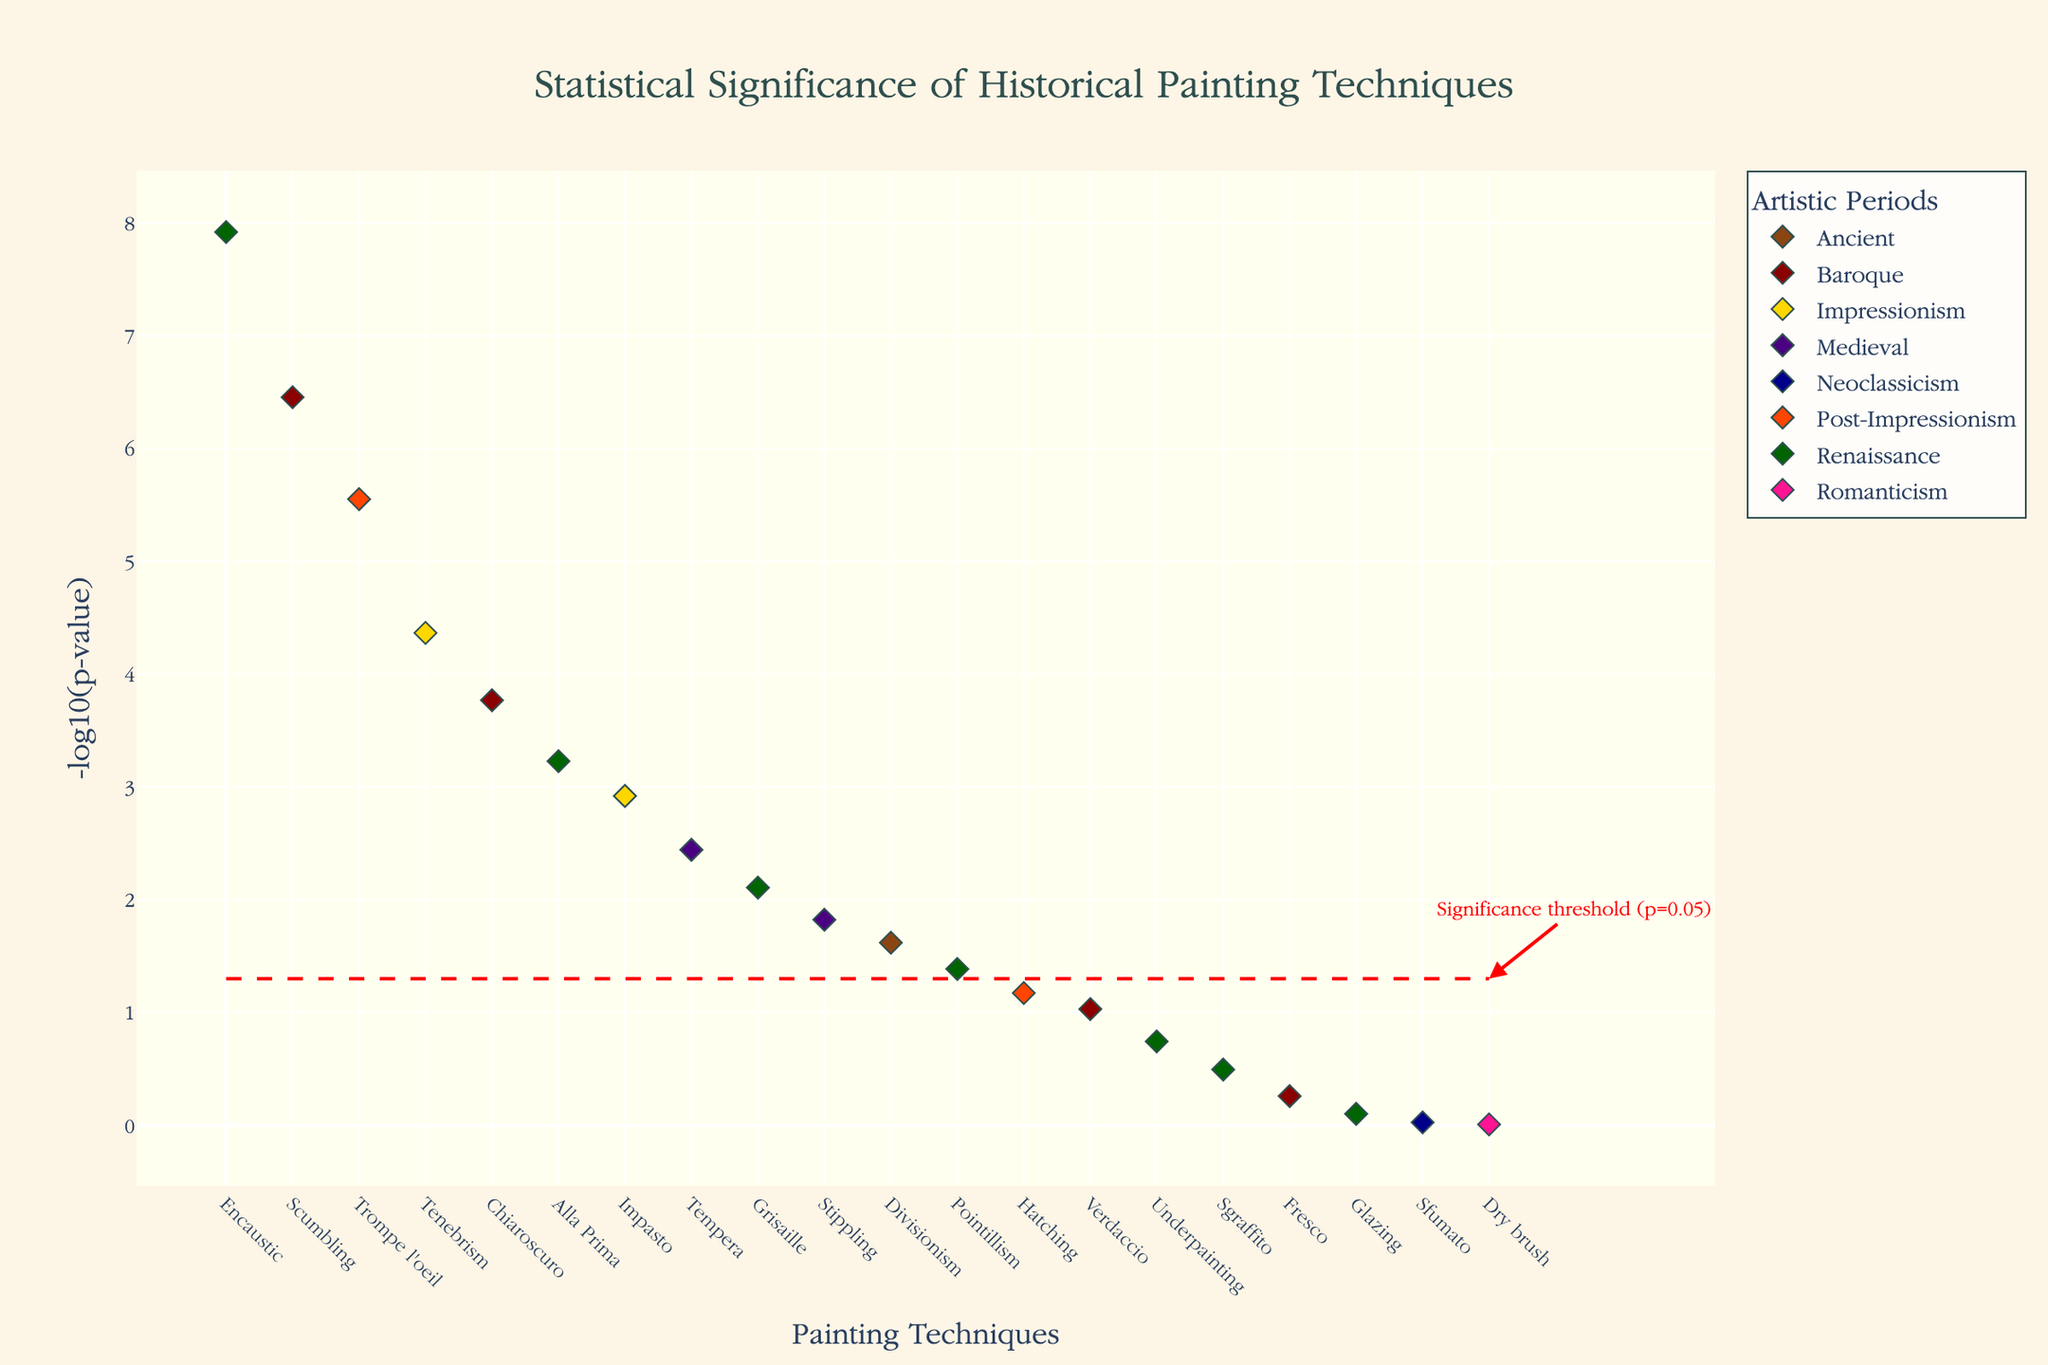What is the title of the plot? The title of the plot is prominently displayed at the top and provides a clear summary of the figure's content.
Answer: Statistical Significance of Historical Painting Techniques Which painting technique had the most significant p-value? The point with the highest -log10(p-value) represents the most significant p-value. In this plot, the tallest point corresponds to the 'Sfumato' technique.
Answer: Sfumato How many painting techniques have p-values less than 0.05? The significance threshold line at -log10(p-value) of 1.3 indicates p = 0.05. Count the points above this line to determine how many techniques have p-values less than 0.05.
Answer: 10 Which period has the highest number of statistically significant techniques? To find the period with the most significant techniques, count the number of points above the red significance threshold line and categorize them by their period color. The 'Renaissance' period shows the majority above this line.
Answer: Renaissance What are the p-values for techniques from the Baroque period? Identify the color associated with the Baroque period, then locate and list the p-values of points in that color. The Baroque period techniques are 'Chiaroscuro' (3.5e-7), 'Tenebrism' (1.7e-4), 'Trompe l'oeil' (9.3e-2), and 'Scumbling' (5.5e-1).
Answer: 3.5e-7, 1.7e-4, 9.3e-2, and 5.5e-1 Which technique is labeled from the Neoclassicism period? The Neoclassicism period is typically represented with a specific color. Find the point with this color to determine the technique, which is 'Stippling'.
Answer: Stippling Is Tenebrism more or less significant than Impasto? Compare the -log10(p-value) of 'Tenebrism' and 'Impasto' on the y-axis. 'Tenebrism' has a higher -log10(p-value) than 'Impasto', indicating greater significance.
Answer: More significant List the Renaissance techniques with p-values less than 0.05. Identify the points from the Renaissance period (green color) and check their positions relative to the significance threshold. The Renaissance techniques below this threshold are 'Sfumato', 'Glazing', and 'Fresco'.
Answer: Sfumato, Glazing, Fresco What is the -log10(p-value) of the Glazing technique? Locate the point representing 'Glazing' on the plot and read its -log10(p-value) from the y-axis. The Glazing technique's p-value is approximately 5.9e-4, translating to a y-value.
Answer: ~3.23 